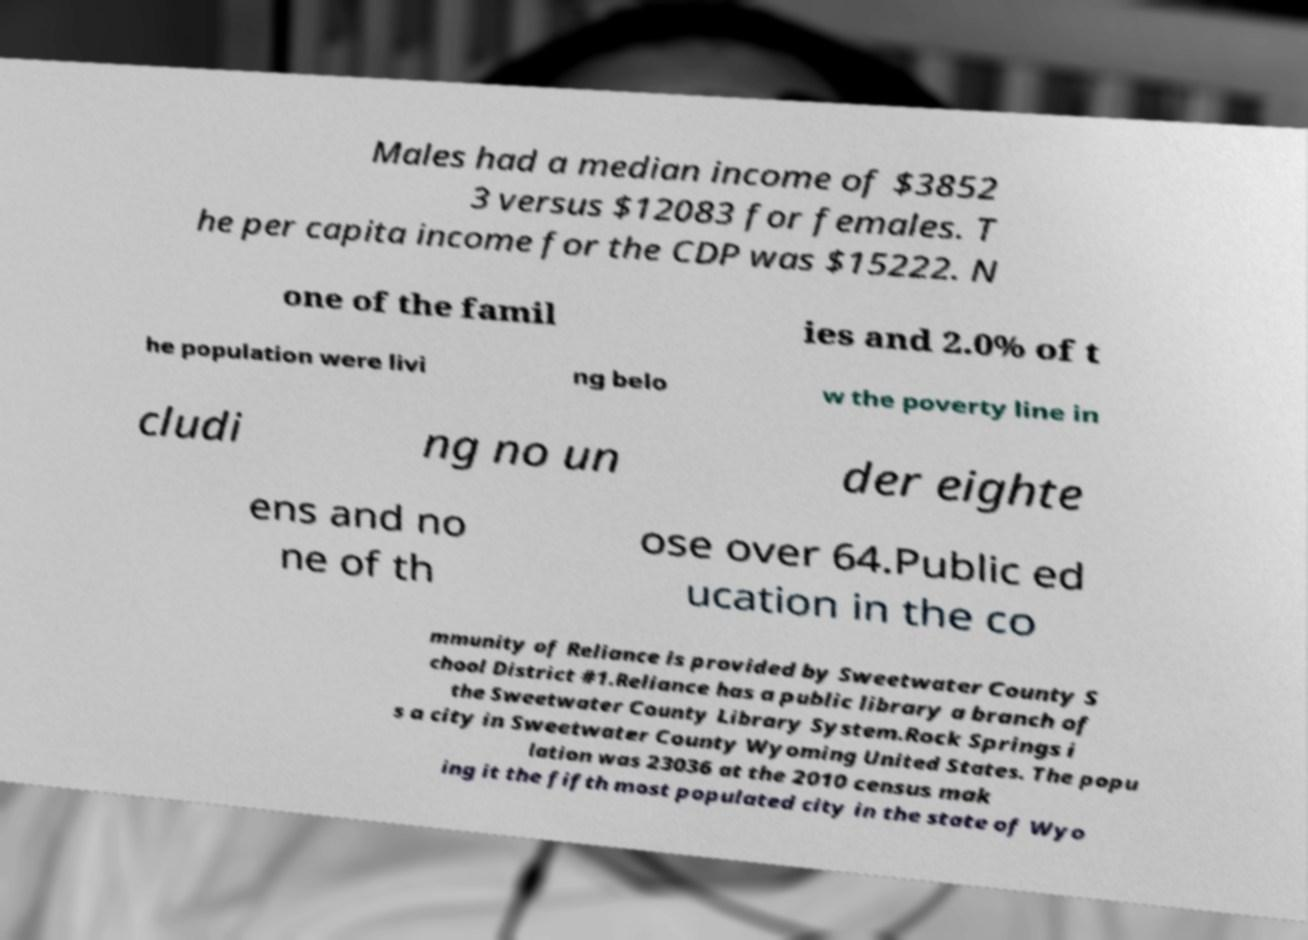Please identify and transcribe the text found in this image. Males had a median income of $3852 3 versus $12083 for females. T he per capita income for the CDP was $15222. N one of the famil ies and 2.0% of t he population were livi ng belo w the poverty line in cludi ng no un der eighte ens and no ne of th ose over 64.Public ed ucation in the co mmunity of Reliance is provided by Sweetwater County S chool District #1.Reliance has a public library a branch of the Sweetwater County Library System.Rock Springs i s a city in Sweetwater County Wyoming United States. The popu lation was 23036 at the 2010 census mak ing it the fifth most populated city in the state of Wyo 